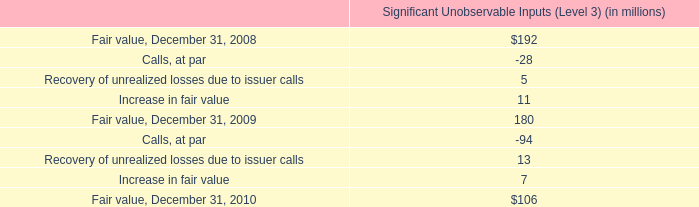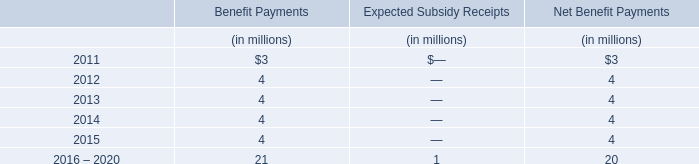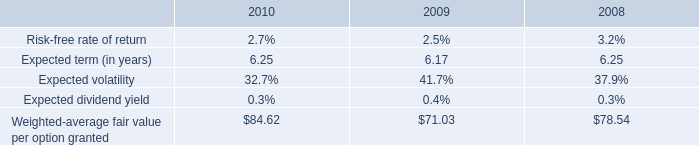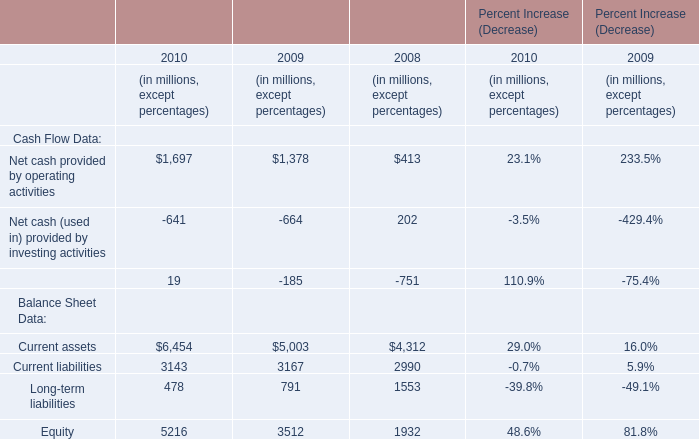what is the percentual decrease observed in the fair value of ars investments between 2009 and 2008? 
Computations: ((180 - 192) / 192)
Answer: -0.0625. 